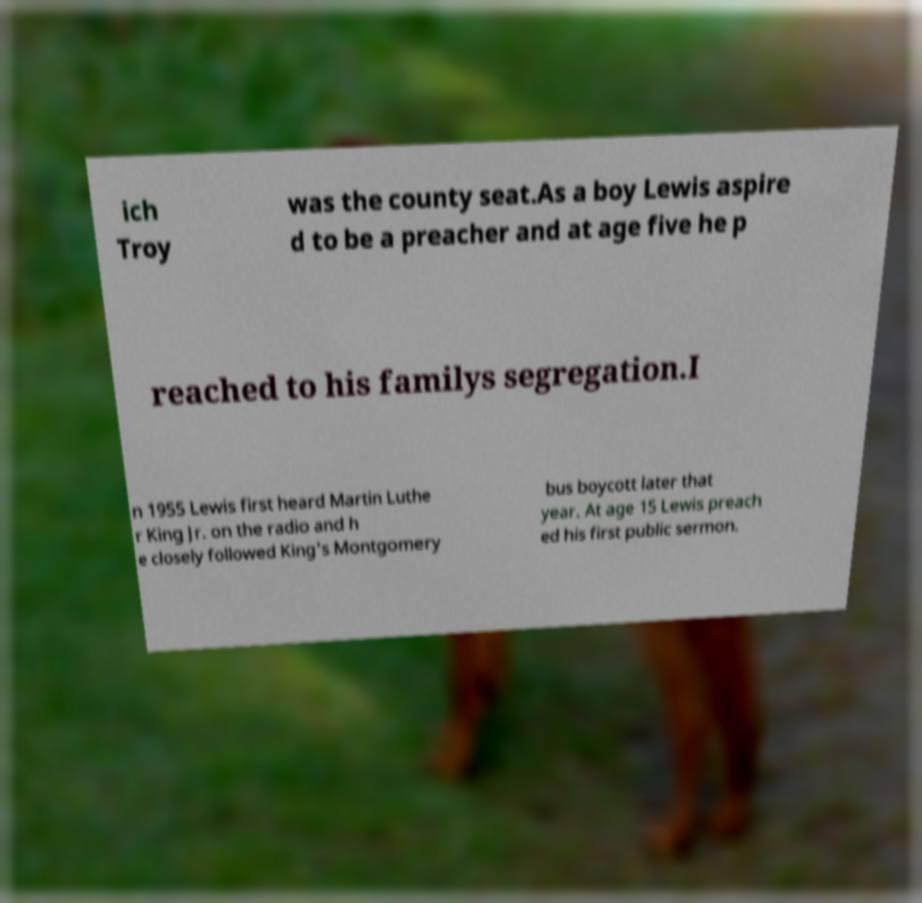Can you read and provide the text displayed in the image?This photo seems to have some interesting text. Can you extract and type it out for me? ich Troy was the county seat.As a boy Lewis aspire d to be a preacher and at age five he p reached to his familys segregation.I n 1955 Lewis first heard Martin Luthe r King Jr. on the radio and h e closely followed King's Montgomery bus boycott later that year. At age 15 Lewis preach ed his first public sermon. 